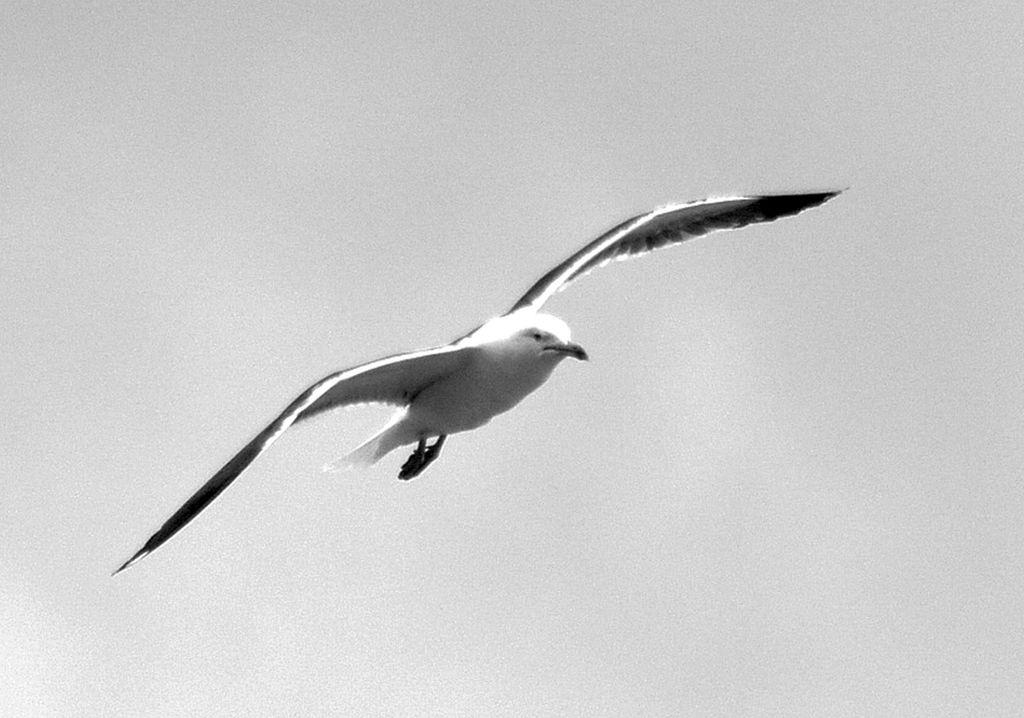What type of animal can be seen in the image? There is a bird in the image. What is the bird doing in the image? The bird is flying. What color is the bird in the image? The bird is white in color. What can be seen in the background of the image? There is a sky visible in the background of the image. What type of plant is the bird using to expand its mind in the image? There is no plant or indication of the bird expanding its mind in the image; it is simply flying. 